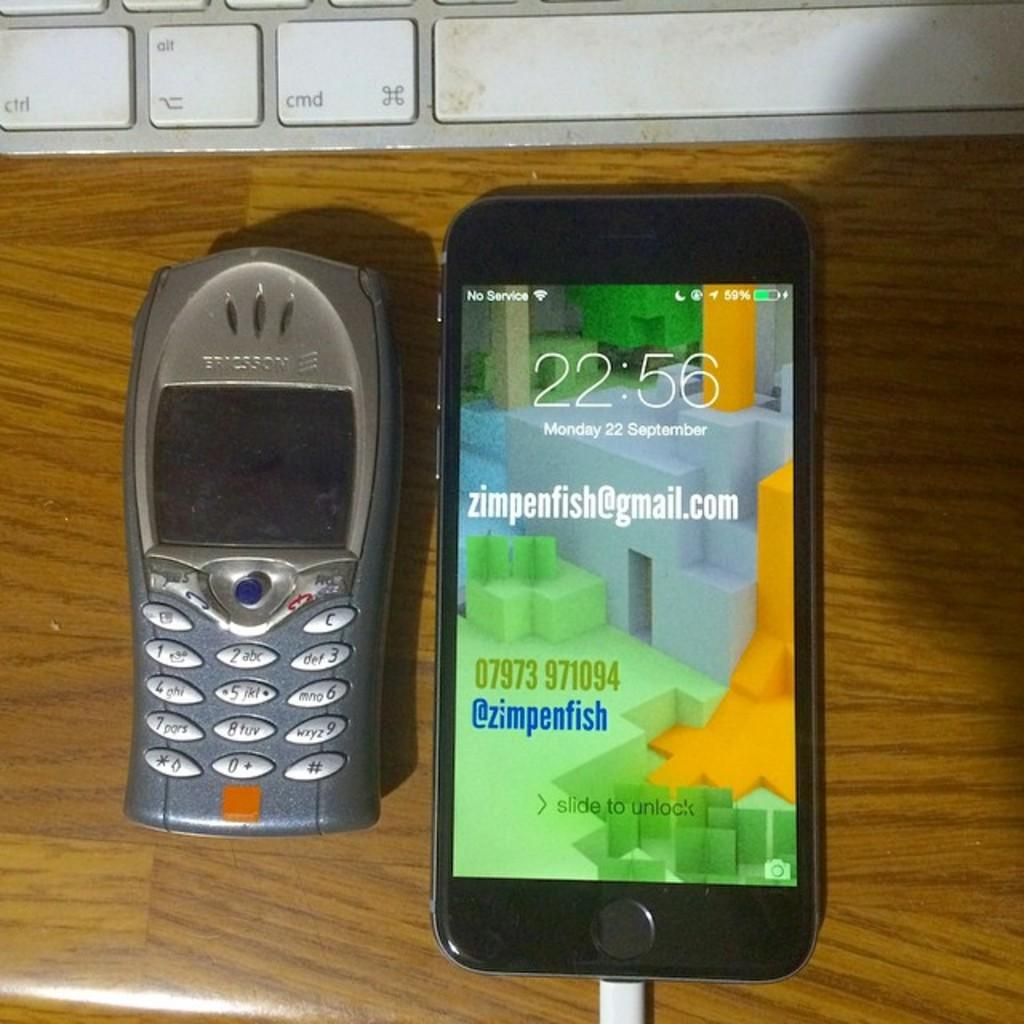What electronic devices can be seen in the image? There are mobile phones in the image. What other object related to technology is present in the image? There is a keyboard in the image. What is the color of the surface the objects are placed on? The surface the objects are on is brown in color. Where is the rabbit hiding in the image? There is no rabbit present in the image. What type of mark can be seen on the keyboard in the image? There is no mention of any mark on the keyboard in the facts. 